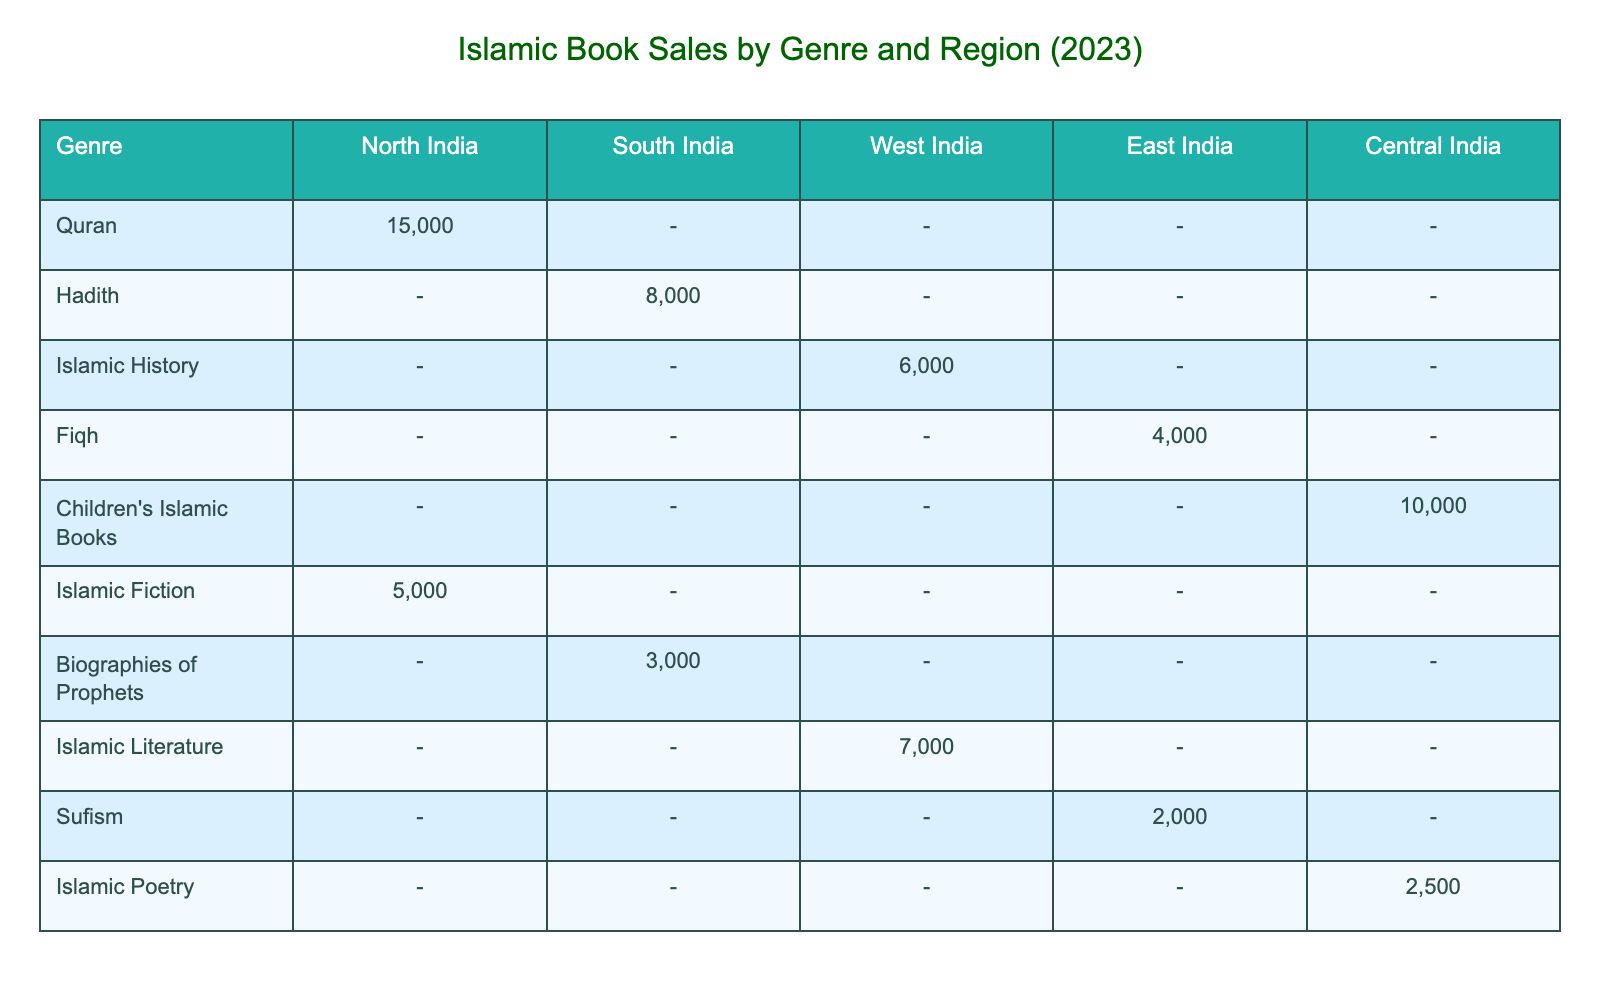What is the total sales volume of Qurans sold in North India? From the table, the sales volume for the Quran in North India is listed as 15,000 units. Therefore, the total sales volume is just that number.
Answer: 15,000 units Which genre had the highest total revenue in South India? Looking at the South India column for total revenue, Hadith generated INR 2,000,000 and Biographies of Prophets generated INR 1,500,000. Since 2,000,000 is higher, Hadith is the genre with the highest revenue.
Answer: Hadith What is the total sales volume for Islamic Literature in West India? The table shows that Islamic Literature had a sales volume of 7,000 units in West India. This directly answers the query about the total sales volume for that genre in that region.
Answer: 7,000 units Is the average price of Islamic Poetry in Central India greater than the average price of Fiqh in East India? The average price for Islamic Poetry is INR 200, and for Fiqh, it is INR 350. Since 200 is less than 350, the statement is false.
Answer: No What is the total revenue from Children’s Islamic Books in Central India and how does it compare to the total revenue from Islamic Fiction in North India? The total revenue from Children’s Islamic Books in Central India is INR 1,500,000, and for Islamic Fiction in North India, it is INR 1,250,000. Comparing the two, 1,500,000 is greater than 1,250,000. Therefore, Children’s Islamic Books has a higher revenue.
Answer: Children’s Islamic Books has a higher revenue Which region sold the least number of Islamic books across all genres combined? To find the region with the least sales, we need to sum the sales volumes by region: North India (15,000 + 5,000 = 20,000), South India (8,000 + 3,000 = 11,000), West India (6,000 + 7,000 = 13,000), East India (4,000 + 2,000 = 6,000), Central India (10,000 + 2,500 = 12,500). The least total sales come from East India, at 6,000 units.
Answer: East India What is the average price of Islamic books sold in North India? The average prices for North India are for Quran (INR 300) and Islamic Fiction (INR 250). The average is calculated as (300 + 250) / 2 = 275. Therefore, the average price of Islamic books sold in North India is INR 275.
Answer: INR 275 How many more units of Hadith were sold in South India compared to Islamic History sold in West India? The sales volume for Hadith in South India is 8,000 units, and for Islamic History in West India, it is 6,000 units. Subtracting these gives us 8,000 - 6,000 = 2,000 units more sold for Hadith compared to Islamic History.
Answer: 2,000 units more Which genre across all regions had a sales volume greater than 6,000 units? Looking through the sales volumes, Quran (15,000), Hadith (8,000), Islamic Literature (7,000), and Children’s Islamic Books (10,000) are greater than 6,000 units. Therefore, the genres with sales greater than 6,000 units are: Quran, Hadith, Islamic Literature, and Children’s Islamic Books.
Answer: Quran, Hadith, Islamic Literature, Children's Islamic Books 